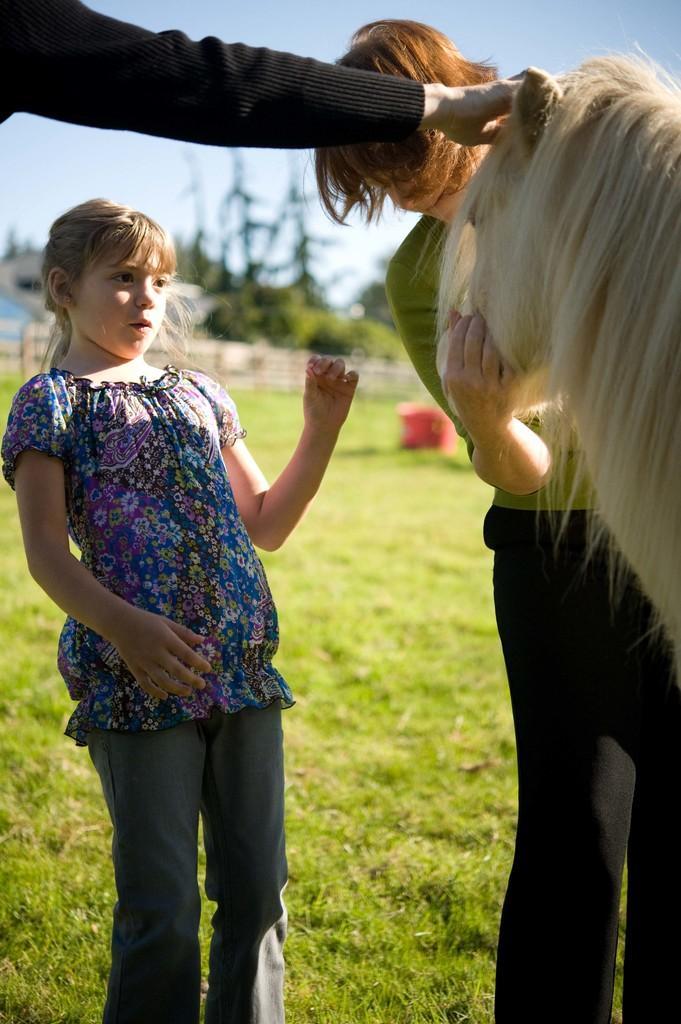Describe this image in one or two sentences. In this image we can see few people. There is the sky in the image. There is a grassy land in the image. There is a fencing in the image. There is an animal at the right side of the image. 